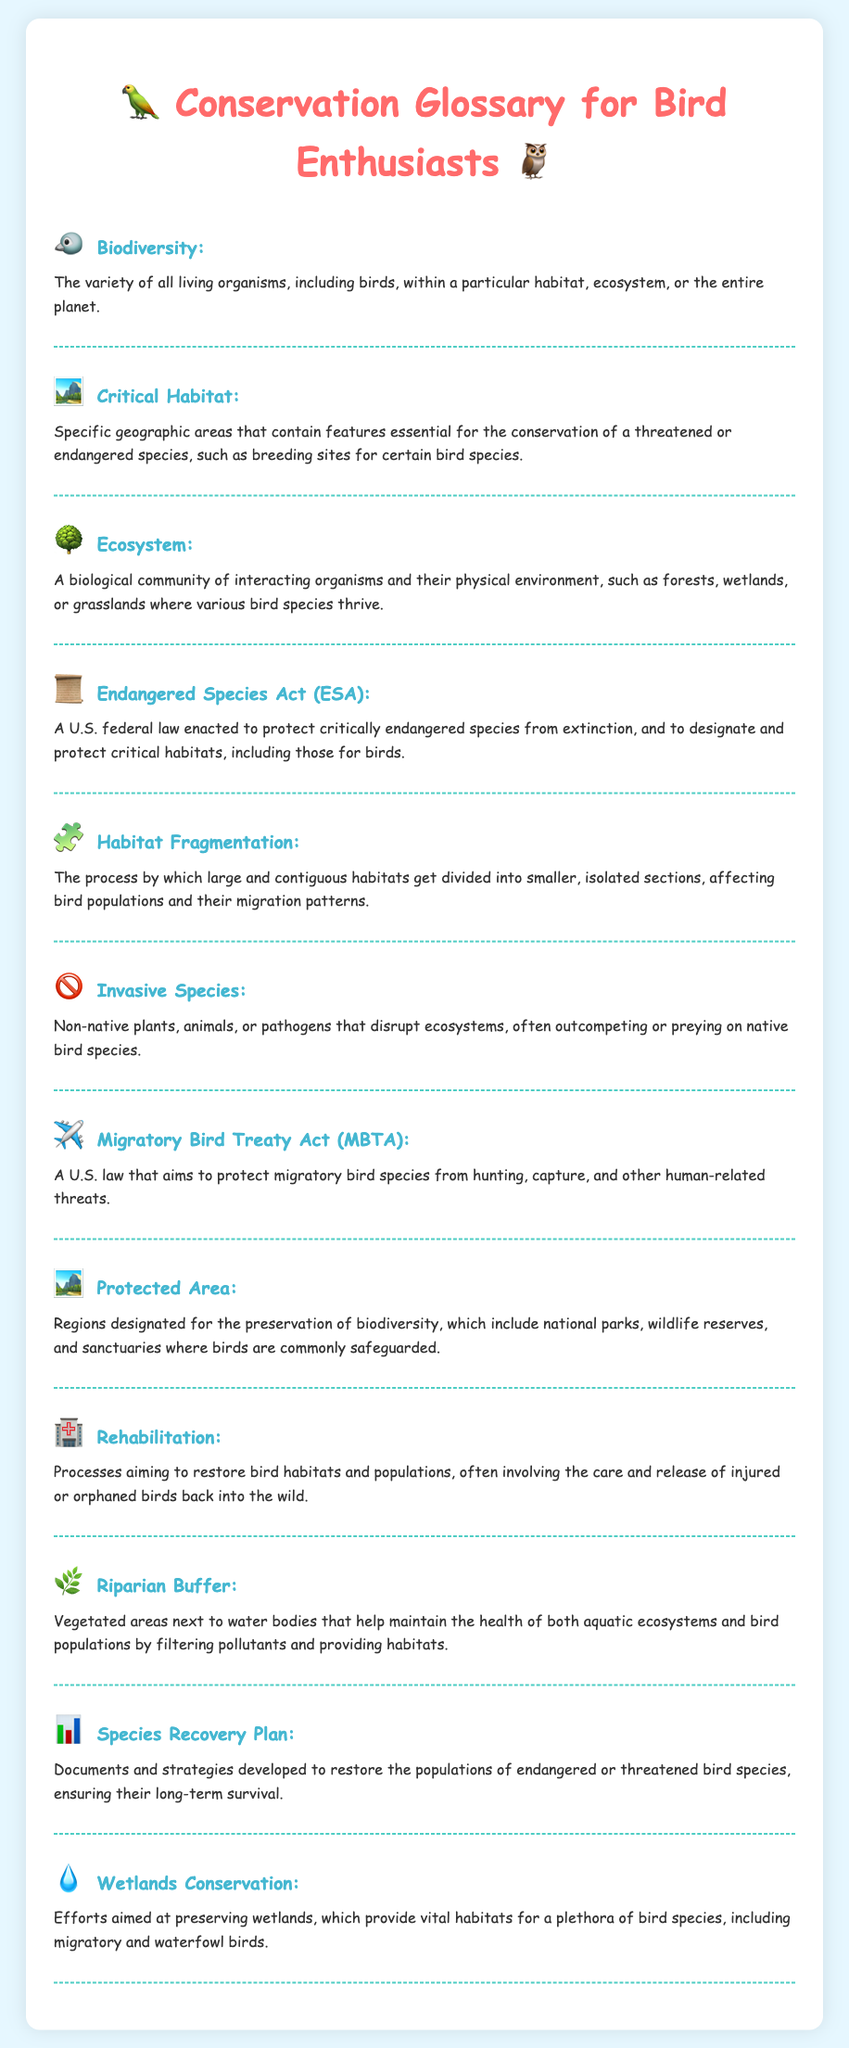What is the definition of Biodiversity? The definition of Biodiversity is provided in the document, emphasizing its importance in conservation.
Answer: The variety of all living organisms, including birds, within a particular habitat, ecosystem, or the entire planet What does Critical Habitat refer to? The document specifies what Critical Habitat means in the context of conservation efforts for bird species.
Answer: Specific geographic areas that contain features essential for the conservation of a threatened or endangered species, such as breeding sites for certain bird species What does the Endangered Species Act protect? The document mentions that the Endangered Species Act is a law aimed at protecting specific species and habitats.
Answer: Critically endangered species from extinction What is Habitat Fragmentation? The document describes Habitat Fragmentation and its impact on bird populations.
Answer: The process by which large and contiguous habitats get divided into smaller, isolated sections Which law protects migratory birds? The document contains information about a law focused on the protection of migratory birds.
Answer: Migratory Bird Treaty Act (MBTA) How do wetlands benefit bird species? The document highlights the importance of wetlands in conservation for birds.
Answer: Provide vital habitats for a plethora of bird species, including migratory and waterfowl birds What is a Species Recovery Plan? The document defines what a Species Recovery Plan entails for bird conservation.
Answer: Documents and strategies developed to restore the populations of endangered or threatened bird species What is an Invasive Species? The document explains the concept of Invasive Species in relation to ecosystems.
Answer: Non-native plants, animals, or pathogens that disrupt ecosystems 